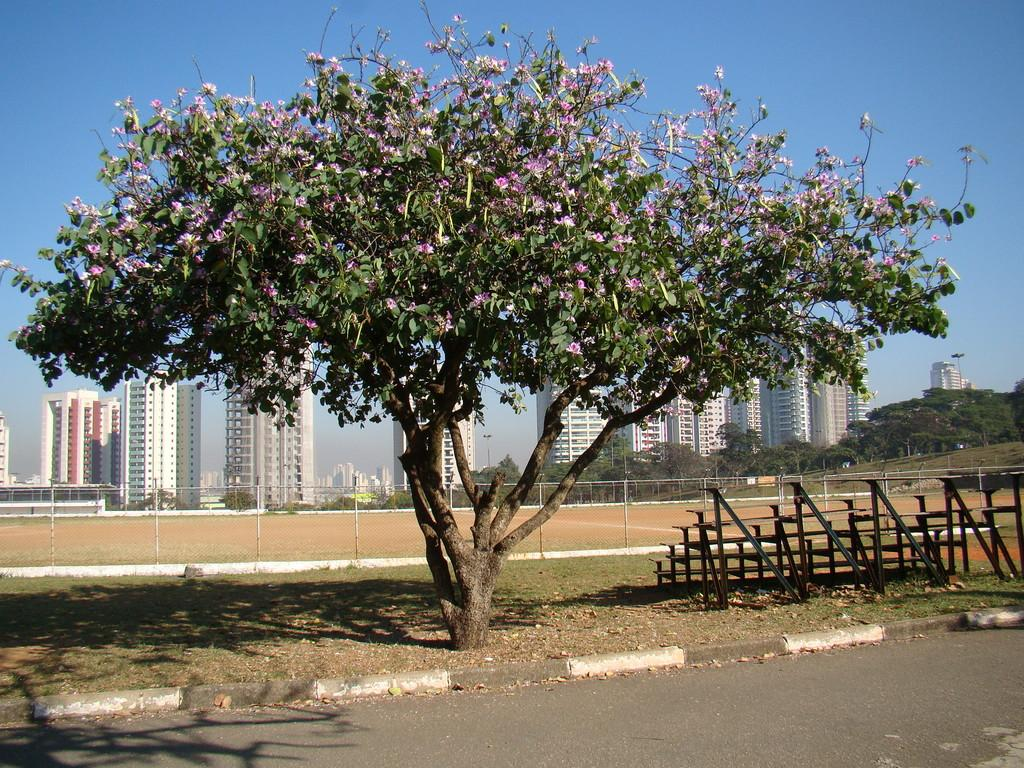What is the main feature of the image? There is a road in the image. What objects are present alongside the road? There are benches and a tree in the image. Can you describe the lighting in the image? There are shadows in the image, indicating that there is a light source. What can be seen in the background of the image? In the background, there is fencing, the ground, multiple trees, buildings, and the sky. What type of poison is being used by the woman in the image? There is no woman present in the image, and therefore no poison or related activity can be observed. 